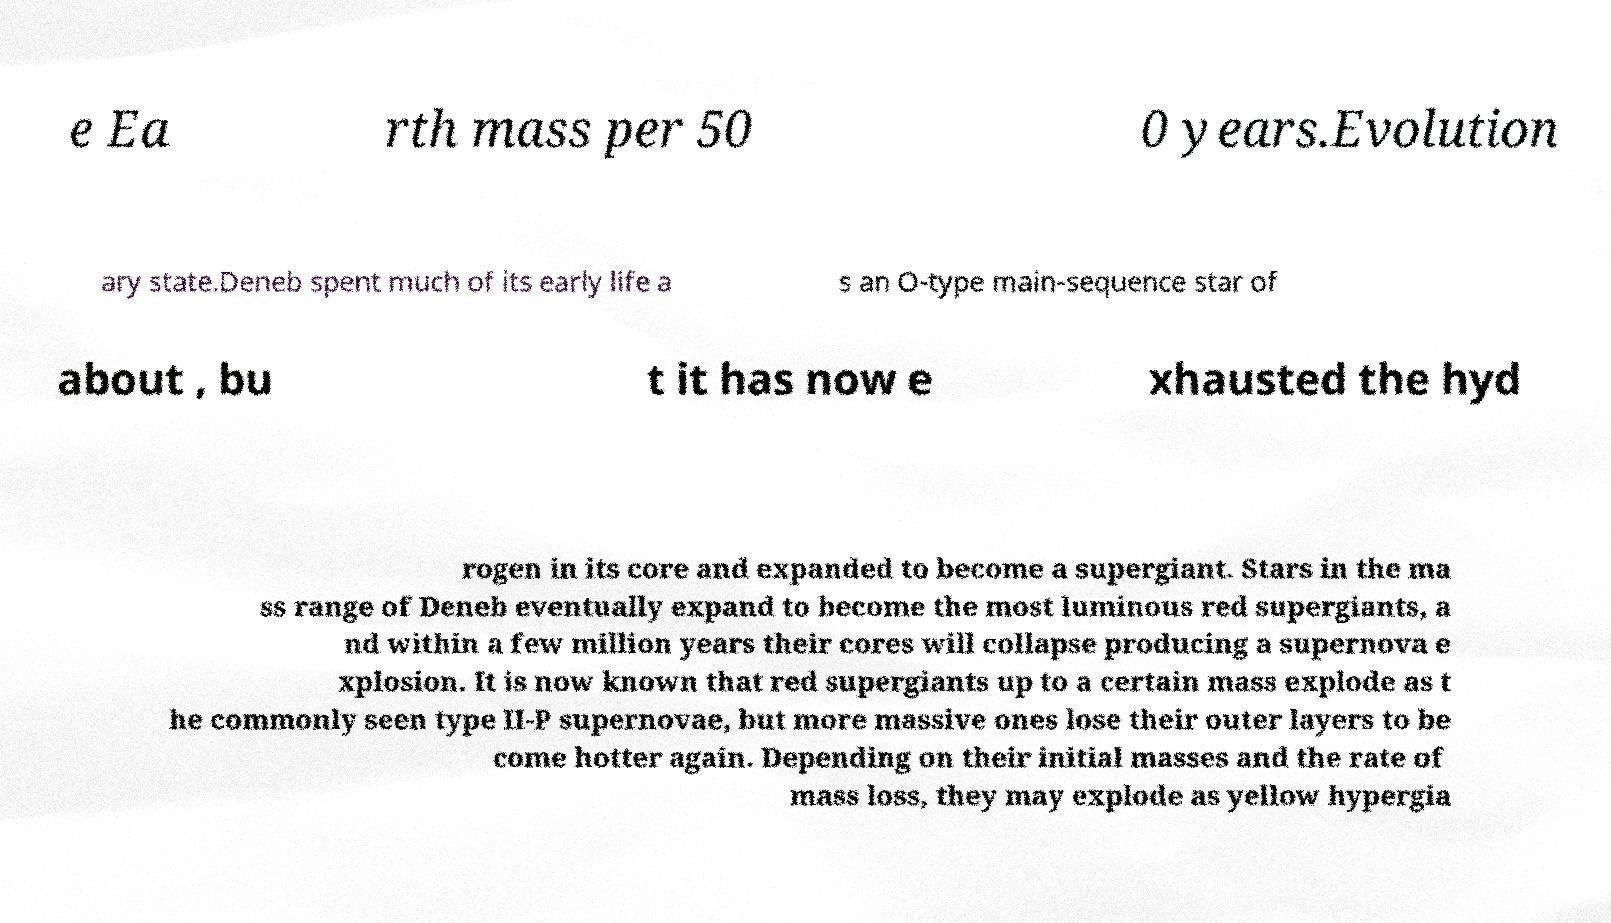What messages or text are displayed in this image? I need them in a readable, typed format. e Ea rth mass per 50 0 years.Evolution ary state.Deneb spent much of its early life a s an O-type main-sequence star of about , bu t it has now e xhausted the hyd rogen in its core and expanded to become a supergiant. Stars in the ma ss range of Deneb eventually expand to become the most luminous red supergiants, a nd within a few million years their cores will collapse producing a supernova e xplosion. It is now known that red supergiants up to a certain mass explode as t he commonly seen type II-P supernovae, but more massive ones lose their outer layers to be come hotter again. Depending on their initial masses and the rate of mass loss, they may explode as yellow hypergia 